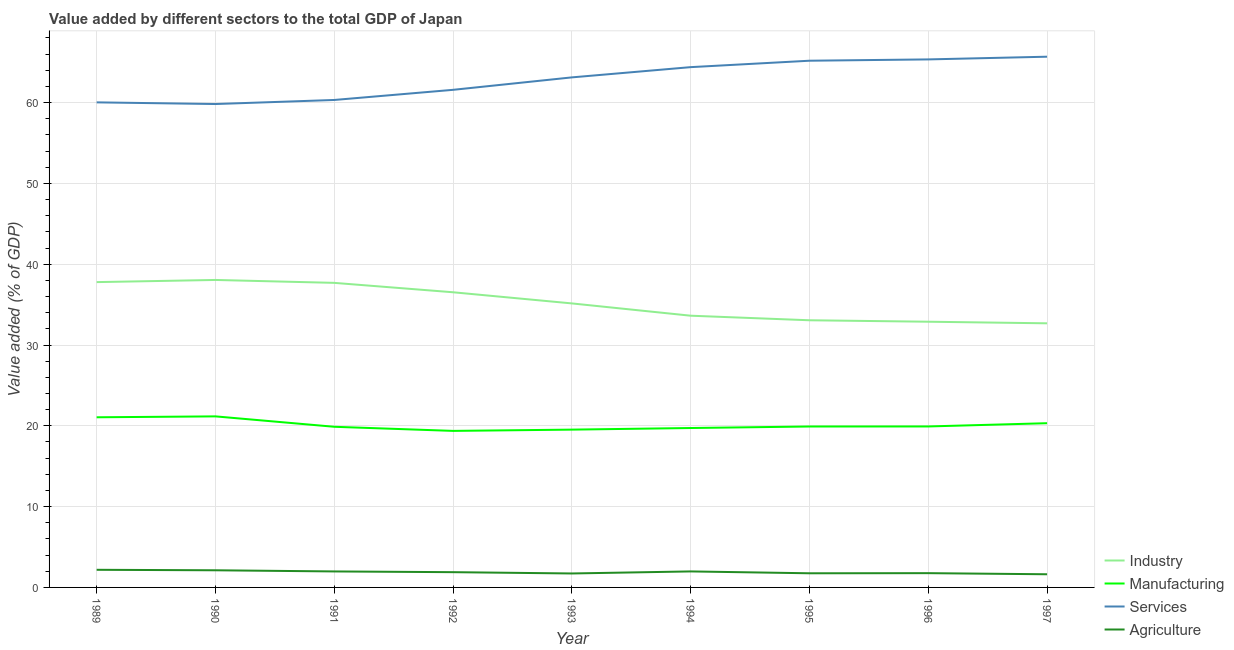How many different coloured lines are there?
Your answer should be compact. 4. Does the line corresponding to value added by manufacturing sector intersect with the line corresponding to value added by agricultural sector?
Offer a terse response. No. Is the number of lines equal to the number of legend labels?
Your response must be concise. Yes. What is the value added by agricultural sector in 1992?
Your response must be concise. 1.89. Across all years, what is the maximum value added by manufacturing sector?
Offer a terse response. 21.17. Across all years, what is the minimum value added by services sector?
Your response must be concise. 59.82. In which year was the value added by industrial sector maximum?
Your response must be concise. 1990. What is the total value added by manufacturing sector in the graph?
Make the answer very short. 180.9. What is the difference between the value added by agricultural sector in 1992 and that in 1997?
Your answer should be very brief. 0.26. What is the difference between the value added by services sector in 1997 and the value added by industrial sector in 1994?
Provide a succinct answer. 32.05. What is the average value added by services sector per year?
Make the answer very short. 62.83. In the year 1996, what is the difference between the value added by agricultural sector and value added by services sector?
Your answer should be compact. -63.58. In how many years, is the value added by manufacturing sector greater than 2 %?
Offer a terse response. 9. What is the ratio of the value added by industrial sector in 1993 to that in 1997?
Offer a very short reply. 1.08. What is the difference between the highest and the second highest value added by agricultural sector?
Offer a very short reply. 0.06. What is the difference between the highest and the lowest value added by agricultural sector?
Offer a terse response. 0.55. In how many years, is the value added by manufacturing sector greater than the average value added by manufacturing sector taken over all years?
Your answer should be very brief. 3. Is it the case that in every year, the sum of the value added by industrial sector and value added by manufacturing sector is greater than the value added by services sector?
Offer a terse response. No. Is the value added by industrial sector strictly greater than the value added by manufacturing sector over the years?
Ensure brevity in your answer.  Yes. Is the value added by industrial sector strictly less than the value added by services sector over the years?
Your response must be concise. Yes. How many lines are there?
Keep it short and to the point. 4. What is the difference between two consecutive major ticks on the Y-axis?
Make the answer very short. 10. What is the title of the graph?
Provide a succinct answer. Value added by different sectors to the total GDP of Japan. Does "HFC gas" appear as one of the legend labels in the graph?
Ensure brevity in your answer.  No. What is the label or title of the X-axis?
Make the answer very short. Year. What is the label or title of the Y-axis?
Ensure brevity in your answer.  Value added (% of GDP). What is the Value added (% of GDP) of Industry in 1989?
Keep it short and to the point. 37.79. What is the Value added (% of GDP) in Manufacturing in 1989?
Your answer should be very brief. 21.06. What is the Value added (% of GDP) of Services in 1989?
Your answer should be very brief. 60.03. What is the Value added (% of GDP) of Agriculture in 1989?
Give a very brief answer. 2.18. What is the Value added (% of GDP) in Industry in 1990?
Give a very brief answer. 38.05. What is the Value added (% of GDP) of Manufacturing in 1990?
Keep it short and to the point. 21.17. What is the Value added (% of GDP) in Services in 1990?
Offer a terse response. 59.82. What is the Value added (% of GDP) in Agriculture in 1990?
Your response must be concise. 2.12. What is the Value added (% of GDP) in Industry in 1991?
Your answer should be compact. 37.69. What is the Value added (% of GDP) in Manufacturing in 1991?
Provide a succinct answer. 19.88. What is the Value added (% of GDP) in Services in 1991?
Your response must be concise. 60.33. What is the Value added (% of GDP) of Agriculture in 1991?
Make the answer very short. 1.98. What is the Value added (% of GDP) of Industry in 1992?
Provide a short and direct response. 36.53. What is the Value added (% of GDP) in Manufacturing in 1992?
Keep it short and to the point. 19.37. What is the Value added (% of GDP) of Services in 1992?
Provide a succinct answer. 61.58. What is the Value added (% of GDP) in Agriculture in 1992?
Provide a succinct answer. 1.89. What is the Value added (% of GDP) of Industry in 1993?
Provide a short and direct response. 35.15. What is the Value added (% of GDP) in Manufacturing in 1993?
Offer a very short reply. 19.53. What is the Value added (% of GDP) in Services in 1993?
Ensure brevity in your answer.  63.12. What is the Value added (% of GDP) of Agriculture in 1993?
Your answer should be very brief. 1.73. What is the Value added (% of GDP) of Industry in 1994?
Offer a very short reply. 33.63. What is the Value added (% of GDP) in Manufacturing in 1994?
Keep it short and to the point. 19.73. What is the Value added (% of GDP) of Services in 1994?
Your answer should be compact. 64.39. What is the Value added (% of GDP) of Agriculture in 1994?
Your answer should be very brief. 1.98. What is the Value added (% of GDP) in Industry in 1995?
Your answer should be very brief. 33.06. What is the Value added (% of GDP) of Manufacturing in 1995?
Provide a succinct answer. 19.92. What is the Value added (% of GDP) in Services in 1995?
Keep it short and to the point. 65.19. What is the Value added (% of GDP) in Agriculture in 1995?
Provide a short and direct response. 1.75. What is the Value added (% of GDP) in Industry in 1996?
Keep it short and to the point. 32.88. What is the Value added (% of GDP) of Manufacturing in 1996?
Offer a very short reply. 19.92. What is the Value added (% of GDP) of Services in 1996?
Offer a very short reply. 65.35. What is the Value added (% of GDP) in Agriculture in 1996?
Your answer should be compact. 1.77. What is the Value added (% of GDP) of Industry in 1997?
Provide a short and direct response. 32.69. What is the Value added (% of GDP) in Manufacturing in 1997?
Your response must be concise. 20.32. What is the Value added (% of GDP) of Services in 1997?
Your response must be concise. 65.68. What is the Value added (% of GDP) of Agriculture in 1997?
Your answer should be compact. 1.63. Across all years, what is the maximum Value added (% of GDP) in Industry?
Provide a succinct answer. 38.05. Across all years, what is the maximum Value added (% of GDP) in Manufacturing?
Ensure brevity in your answer.  21.17. Across all years, what is the maximum Value added (% of GDP) of Services?
Provide a succinct answer. 65.68. Across all years, what is the maximum Value added (% of GDP) in Agriculture?
Ensure brevity in your answer.  2.18. Across all years, what is the minimum Value added (% of GDP) in Industry?
Keep it short and to the point. 32.69. Across all years, what is the minimum Value added (% of GDP) of Manufacturing?
Your answer should be compact. 19.37. Across all years, what is the minimum Value added (% of GDP) of Services?
Keep it short and to the point. 59.82. Across all years, what is the minimum Value added (% of GDP) of Agriculture?
Ensure brevity in your answer.  1.63. What is the total Value added (% of GDP) in Industry in the graph?
Keep it short and to the point. 317.48. What is the total Value added (% of GDP) of Manufacturing in the graph?
Ensure brevity in your answer.  180.9. What is the total Value added (% of GDP) of Services in the graph?
Offer a terse response. 565.5. What is the total Value added (% of GDP) of Agriculture in the graph?
Your answer should be compact. 17.02. What is the difference between the Value added (% of GDP) in Industry in 1989 and that in 1990?
Keep it short and to the point. -0.27. What is the difference between the Value added (% of GDP) of Manufacturing in 1989 and that in 1990?
Your response must be concise. -0.11. What is the difference between the Value added (% of GDP) in Services in 1989 and that in 1990?
Keep it short and to the point. 0.21. What is the difference between the Value added (% of GDP) in Agriculture in 1989 and that in 1990?
Your response must be concise. 0.06. What is the difference between the Value added (% of GDP) in Industry in 1989 and that in 1991?
Your answer should be very brief. 0.09. What is the difference between the Value added (% of GDP) in Manufacturing in 1989 and that in 1991?
Your answer should be compact. 1.17. What is the difference between the Value added (% of GDP) of Services in 1989 and that in 1991?
Provide a succinct answer. -0.3. What is the difference between the Value added (% of GDP) in Agriculture in 1989 and that in 1991?
Your answer should be compact. 0.2. What is the difference between the Value added (% of GDP) of Industry in 1989 and that in 1992?
Provide a succinct answer. 1.26. What is the difference between the Value added (% of GDP) of Manufacturing in 1989 and that in 1992?
Make the answer very short. 1.68. What is the difference between the Value added (% of GDP) in Services in 1989 and that in 1992?
Give a very brief answer. -1.55. What is the difference between the Value added (% of GDP) of Agriculture in 1989 and that in 1992?
Give a very brief answer. 0.3. What is the difference between the Value added (% of GDP) of Industry in 1989 and that in 1993?
Provide a succinct answer. 2.64. What is the difference between the Value added (% of GDP) of Manufacturing in 1989 and that in 1993?
Offer a very short reply. 1.53. What is the difference between the Value added (% of GDP) of Services in 1989 and that in 1993?
Provide a short and direct response. -3.09. What is the difference between the Value added (% of GDP) in Agriculture in 1989 and that in 1993?
Ensure brevity in your answer.  0.45. What is the difference between the Value added (% of GDP) in Industry in 1989 and that in 1994?
Your response must be concise. 4.16. What is the difference between the Value added (% of GDP) in Manufacturing in 1989 and that in 1994?
Offer a very short reply. 1.33. What is the difference between the Value added (% of GDP) in Services in 1989 and that in 1994?
Keep it short and to the point. -4.36. What is the difference between the Value added (% of GDP) in Agriculture in 1989 and that in 1994?
Make the answer very short. 0.2. What is the difference between the Value added (% of GDP) of Industry in 1989 and that in 1995?
Give a very brief answer. 4.72. What is the difference between the Value added (% of GDP) in Manufacturing in 1989 and that in 1995?
Offer a very short reply. 1.14. What is the difference between the Value added (% of GDP) of Services in 1989 and that in 1995?
Your answer should be very brief. -5.15. What is the difference between the Value added (% of GDP) of Agriculture in 1989 and that in 1995?
Offer a terse response. 0.43. What is the difference between the Value added (% of GDP) in Industry in 1989 and that in 1996?
Ensure brevity in your answer.  4.9. What is the difference between the Value added (% of GDP) in Manufacturing in 1989 and that in 1996?
Offer a terse response. 1.13. What is the difference between the Value added (% of GDP) of Services in 1989 and that in 1996?
Your response must be concise. -5.32. What is the difference between the Value added (% of GDP) in Agriculture in 1989 and that in 1996?
Your answer should be compact. 0.42. What is the difference between the Value added (% of GDP) in Industry in 1989 and that in 1997?
Provide a succinct answer. 5.1. What is the difference between the Value added (% of GDP) of Manufacturing in 1989 and that in 1997?
Keep it short and to the point. 0.73. What is the difference between the Value added (% of GDP) in Services in 1989 and that in 1997?
Your response must be concise. -5.65. What is the difference between the Value added (% of GDP) in Agriculture in 1989 and that in 1997?
Ensure brevity in your answer.  0.55. What is the difference between the Value added (% of GDP) in Industry in 1990 and that in 1991?
Make the answer very short. 0.36. What is the difference between the Value added (% of GDP) in Manufacturing in 1990 and that in 1991?
Your response must be concise. 1.29. What is the difference between the Value added (% of GDP) in Services in 1990 and that in 1991?
Your answer should be very brief. -0.5. What is the difference between the Value added (% of GDP) in Agriculture in 1990 and that in 1991?
Your response must be concise. 0.14. What is the difference between the Value added (% of GDP) in Industry in 1990 and that in 1992?
Provide a succinct answer. 1.52. What is the difference between the Value added (% of GDP) of Manufacturing in 1990 and that in 1992?
Provide a short and direct response. 1.8. What is the difference between the Value added (% of GDP) in Services in 1990 and that in 1992?
Your response must be concise. -1.76. What is the difference between the Value added (% of GDP) of Agriculture in 1990 and that in 1992?
Keep it short and to the point. 0.23. What is the difference between the Value added (% of GDP) in Industry in 1990 and that in 1993?
Offer a terse response. 2.9. What is the difference between the Value added (% of GDP) in Manufacturing in 1990 and that in 1993?
Make the answer very short. 1.64. What is the difference between the Value added (% of GDP) of Services in 1990 and that in 1993?
Your answer should be compact. -3.3. What is the difference between the Value added (% of GDP) of Agriculture in 1990 and that in 1993?
Ensure brevity in your answer.  0.39. What is the difference between the Value added (% of GDP) of Industry in 1990 and that in 1994?
Your answer should be very brief. 4.42. What is the difference between the Value added (% of GDP) of Manufacturing in 1990 and that in 1994?
Provide a short and direct response. 1.44. What is the difference between the Value added (% of GDP) of Services in 1990 and that in 1994?
Make the answer very short. -4.57. What is the difference between the Value added (% of GDP) in Agriculture in 1990 and that in 1994?
Give a very brief answer. 0.14. What is the difference between the Value added (% of GDP) in Industry in 1990 and that in 1995?
Your response must be concise. 4.99. What is the difference between the Value added (% of GDP) of Manufacturing in 1990 and that in 1995?
Provide a succinct answer. 1.25. What is the difference between the Value added (% of GDP) of Services in 1990 and that in 1995?
Provide a short and direct response. -5.36. What is the difference between the Value added (% of GDP) of Agriculture in 1990 and that in 1995?
Make the answer very short. 0.37. What is the difference between the Value added (% of GDP) in Industry in 1990 and that in 1996?
Offer a very short reply. 5.17. What is the difference between the Value added (% of GDP) of Manufacturing in 1990 and that in 1996?
Give a very brief answer. 1.25. What is the difference between the Value added (% of GDP) in Services in 1990 and that in 1996?
Ensure brevity in your answer.  -5.52. What is the difference between the Value added (% of GDP) of Agriculture in 1990 and that in 1996?
Your response must be concise. 0.35. What is the difference between the Value added (% of GDP) in Industry in 1990 and that in 1997?
Offer a terse response. 5.37. What is the difference between the Value added (% of GDP) of Manufacturing in 1990 and that in 1997?
Offer a terse response. 0.84. What is the difference between the Value added (% of GDP) of Services in 1990 and that in 1997?
Your answer should be very brief. -5.86. What is the difference between the Value added (% of GDP) of Agriculture in 1990 and that in 1997?
Give a very brief answer. 0.49. What is the difference between the Value added (% of GDP) of Industry in 1991 and that in 1992?
Give a very brief answer. 1.16. What is the difference between the Value added (% of GDP) in Manufacturing in 1991 and that in 1992?
Provide a succinct answer. 0.51. What is the difference between the Value added (% of GDP) of Services in 1991 and that in 1992?
Your answer should be compact. -1.25. What is the difference between the Value added (% of GDP) in Agriculture in 1991 and that in 1992?
Make the answer very short. 0.09. What is the difference between the Value added (% of GDP) of Industry in 1991 and that in 1993?
Ensure brevity in your answer.  2.54. What is the difference between the Value added (% of GDP) of Manufacturing in 1991 and that in 1993?
Provide a short and direct response. 0.35. What is the difference between the Value added (% of GDP) in Services in 1991 and that in 1993?
Your answer should be compact. -2.79. What is the difference between the Value added (% of GDP) in Agriculture in 1991 and that in 1993?
Ensure brevity in your answer.  0.25. What is the difference between the Value added (% of GDP) of Industry in 1991 and that in 1994?
Make the answer very short. 4.06. What is the difference between the Value added (% of GDP) of Manufacturing in 1991 and that in 1994?
Give a very brief answer. 0.15. What is the difference between the Value added (% of GDP) of Services in 1991 and that in 1994?
Make the answer very short. -4.06. What is the difference between the Value added (% of GDP) in Agriculture in 1991 and that in 1994?
Your answer should be very brief. -0. What is the difference between the Value added (% of GDP) of Industry in 1991 and that in 1995?
Ensure brevity in your answer.  4.63. What is the difference between the Value added (% of GDP) in Manufacturing in 1991 and that in 1995?
Make the answer very short. -0.03. What is the difference between the Value added (% of GDP) in Services in 1991 and that in 1995?
Give a very brief answer. -4.86. What is the difference between the Value added (% of GDP) in Agriculture in 1991 and that in 1995?
Keep it short and to the point. 0.23. What is the difference between the Value added (% of GDP) in Industry in 1991 and that in 1996?
Your answer should be compact. 4.81. What is the difference between the Value added (% of GDP) of Manufacturing in 1991 and that in 1996?
Your answer should be very brief. -0.04. What is the difference between the Value added (% of GDP) in Services in 1991 and that in 1996?
Your answer should be compact. -5.02. What is the difference between the Value added (% of GDP) of Agriculture in 1991 and that in 1996?
Provide a succinct answer. 0.21. What is the difference between the Value added (% of GDP) in Industry in 1991 and that in 1997?
Your answer should be compact. 5. What is the difference between the Value added (% of GDP) of Manufacturing in 1991 and that in 1997?
Provide a succinct answer. -0.44. What is the difference between the Value added (% of GDP) of Services in 1991 and that in 1997?
Your response must be concise. -5.35. What is the difference between the Value added (% of GDP) of Agriculture in 1991 and that in 1997?
Your answer should be very brief. 0.35. What is the difference between the Value added (% of GDP) of Industry in 1992 and that in 1993?
Ensure brevity in your answer.  1.38. What is the difference between the Value added (% of GDP) of Manufacturing in 1992 and that in 1993?
Provide a succinct answer. -0.16. What is the difference between the Value added (% of GDP) in Services in 1992 and that in 1993?
Offer a very short reply. -1.54. What is the difference between the Value added (% of GDP) of Agriculture in 1992 and that in 1993?
Your response must be concise. 0.16. What is the difference between the Value added (% of GDP) of Industry in 1992 and that in 1994?
Provide a succinct answer. 2.9. What is the difference between the Value added (% of GDP) in Manufacturing in 1992 and that in 1994?
Offer a very short reply. -0.36. What is the difference between the Value added (% of GDP) in Services in 1992 and that in 1994?
Your response must be concise. -2.81. What is the difference between the Value added (% of GDP) in Agriculture in 1992 and that in 1994?
Make the answer very short. -0.09. What is the difference between the Value added (% of GDP) in Industry in 1992 and that in 1995?
Give a very brief answer. 3.47. What is the difference between the Value added (% of GDP) of Manufacturing in 1992 and that in 1995?
Your answer should be compact. -0.54. What is the difference between the Value added (% of GDP) of Services in 1992 and that in 1995?
Offer a terse response. -3.6. What is the difference between the Value added (% of GDP) in Agriculture in 1992 and that in 1995?
Offer a terse response. 0.14. What is the difference between the Value added (% of GDP) in Industry in 1992 and that in 1996?
Provide a succinct answer. 3.64. What is the difference between the Value added (% of GDP) of Manufacturing in 1992 and that in 1996?
Your response must be concise. -0.55. What is the difference between the Value added (% of GDP) in Services in 1992 and that in 1996?
Your answer should be very brief. -3.76. What is the difference between the Value added (% of GDP) in Agriculture in 1992 and that in 1996?
Your answer should be compact. 0.12. What is the difference between the Value added (% of GDP) of Industry in 1992 and that in 1997?
Your answer should be very brief. 3.84. What is the difference between the Value added (% of GDP) in Manufacturing in 1992 and that in 1997?
Ensure brevity in your answer.  -0.95. What is the difference between the Value added (% of GDP) in Services in 1992 and that in 1997?
Offer a very short reply. -4.1. What is the difference between the Value added (% of GDP) in Agriculture in 1992 and that in 1997?
Your answer should be compact. 0.26. What is the difference between the Value added (% of GDP) of Industry in 1993 and that in 1994?
Your answer should be compact. 1.52. What is the difference between the Value added (% of GDP) of Manufacturing in 1993 and that in 1994?
Make the answer very short. -0.2. What is the difference between the Value added (% of GDP) of Services in 1993 and that in 1994?
Ensure brevity in your answer.  -1.27. What is the difference between the Value added (% of GDP) in Agriculture in 1993 and that in 1994?
Offer a terse response. -0.25. What is the difference between the Value added (% of GDP) in Industry in 1993 and that in 1995?
Offer a very short reply. 2.09. What is the difference between the Value added (% of GDP) in Manufacturing in 1993 and that in 1995?
Your response must be concise. -0.38. What is the difference between the Value added (% of GDP) of Services in 1993 and that in 1995?
Keep it short and to the point. -2.06. What is the difference between the Value added (% of GDP) in Agriculture in 1993 and that in 1995?
Provide a short and direct response. -0.02. What is the difference between the Value added (% of GDP) of Industry in 1993 and that in 1996?
Keep it short and to the point. 2.26. What is the difference between the Value added (% of GDP) in Manufacturing in 1993 and that in 1996?
Provide a short and direct response. -0.39. What is the difference between the Value added (% of GDP) of Services in 1993 and that in 1996?
Ensure brevity in your answer.  -2.23. What is the difference between the Value added (% of GDP) of Agriculture in 1993 and that in 1996?
Keep it short and to the point. -0.04. What is the difference between the Value added (% of GDP) in Industry in 1993 and that in 1997?
Provide a short and direct response. 2.46. What is the difference between the Value added (% of GDP) in Manufacturing in 1993 and that in 1997?
Offer a terse response. -0.79. What is the difference between the Value added (% of GDP) in Services in 1993 and that in 1997?
Make the answer very short. -2.56. What is the difference between the Value added (% of GDP) in Agriculture in 1993 and that in 1997?
Give a very brief answer. 0.1. What is the difference between the Value added (% of GDP) in Industry in 1994 and that in 1995?
Offer a very short reply. 0.57. What is the difference between the Value added (% of GDP) in Manufacturing in 1994 and that in 1995?
Give a very brief answer. -0.19. What is the difference between the Value added (% of GDP) in Services in 1994 and that in 1995?
Your answer should be very brief. -0.8. What is the difference between the Value added (% of GDP) in Agriculture in 1994 and that in 1995?
Your answer should be very brief. 0.23. What is the difference between the Value added (% of GDP) of Industry in 1994 and that in 1996?
Offer a terse response. 0.74. What is the difference between the Value added (% of GDP) of Manufacturing in 1994 and that in 1996?
Offer a very short reply. -0.19. What is the difference between the Value added (% of GDP) in Services in 1994 and that in 1996?
Your answer should be compact. -0.96. What is the difference between the Value added (% of GDP) in Agriculture in 1994 and that in 1996?
Your answer should be compact. 0.21. What is the difference between the Value added (% of GDP) of Industry in 1994 and that in 1997?
Provide a short and direct response. 0.94. What is the difference between the Value added (% of GDP) of Manufacturing in 1994 and that in 1997?
Keep it short and to the point. -0.59. What is the difference between the Value added (% of GDP) in Services in 1994 and that in 1997?
Offer a terse response. -1.29. What is the difference between the Value added (% of GDP) in Agriculture in 1994 and that in 1997?
Ensure brevity in your answer.  0.35. What is the difference between the Value added (% of GDP) in Industry in 1995 and that in 1996?
Offer a very short reply. 0.18. What is the difference between the Value added (% of GDP) in Manufacturing in 1995 and that in 1996?
Offer a terse response. -0.01. What is the difference between the Value added (% of GDP) in Services in 1995 and that in 1996?
Give a very brief answer. -0.16. What is the difference between the Value added (% of GDP) of Agriculture in 1995 and that in 1996?
Keep it short and to the point. -0.02. What is the difference between the Value added (% of GDP) of Industry in 1995 and that in 1997?
Make the answer very short. 0.38. What is the difference between the Value added (% of GDP) of Manufacturing in 1995 and that in 1997?
Offer a terse response. -0.41. What is the difference between the Value added (% of GDP) of Services in 1995 and that in 1997?
Provide a succinct answer. -0.5. What is the difference between the Value added (% of GDP) in Agriculture in 1995 and that in 1997?
Make the answer very short. 0.12. What is the difference between the Value added (% of GDP) of Industry in 1996 and that in 1997?
Offer a terse response. 0.2. What is the difference between the Value added (% of GDP) of Manufacturing in 1996 and that in 1997?
Your answer should be compact. -0.4. What is the difference between the Value added (% of GDP) in Services in 1996 and that in 1997?
Provide a succinct answer. -0.33. What is the difference between the Value added (% of GDP) of Agriculture in 1996 and that in 1997?
Ensure brevity in your answer.  0.14. What is the difference between the Value added (% of GDP) of Industry in 1989 and the Value added (% of GDP) of Manufacturing in 1990?
Your answer should be very brief. 16.62. What is the difference between the Value added (% of GDP) of Industry in 1989 and the Value added (% of GDP) of Services in 1990?
Provide a succinct answer. -22.04. What is the difference between the Value added (% of GDP) in Industry in 1989 and the Value added (% of GDP) in Agriculture in 1990?
Your answer should be very brief. 35.66. What is the difference between the Value added (% of GDP) of Manufacturing in 1989 and the Value added (% of GDP) of Services in 1990?
Your response must be concise. -38.77. What is the difference between the Value added (% of GDP) in Manufacturing in 1989 and the Value added (% of GDP) in Agriculture in 1990?
Your response must be concise. 18.94. What is the difference between the Value added (% of GDP) in Services in 1989 and the Value added (% of GDP) in Agriculture in 1990?
Make the answer very short. 57.91. What is the difference between the Value added (% of GDP) in Industry in 1989 and the Value added (% of GDP) in Manufacturing in 1991?
Your response must be concise. 17.9. What is the difference between the Value added (% of GDP) in Industry in 1989 and the Value added (% of GDP) in Services in 1991?
Offer a very short reply. -22.54. What is the difference between the Value added (% of GDP) in Industry in 1989 and the Value added (% of GDP) in Agriculture in 1991?
Provide a short and direct response. 35.81. What is the difference between the Value added (% of GDP) of Manufacturing in 1989 and the Value added (% of GDP) of Services in 1991?
Keep it short and to the point. -39.27. What is the difference between the Value added (% of GDP) in Manufacturing in 1989 and the Value added (% of GDP) in Agriculture in 1991?
Offer a terse response. 19.08. What is the difference between the Value added (% of GDP) in Services in 1989 and the Value added (% of GDP) in Agriculture in 1991?
Provide a short and direct response. 58.05. What is the difference between the Value added (% of GDP) of Industry in 1989 and the Value added (% of GDP) of Manufacturing in 1992?
Your response must be concise. 18.41. What is the difference between the Value added (% of GDP) of Industry in 1989 and the Value added (% of GDP) of Services in 1992?
Give a very brief answer. -23.8. What is the difference between the Value added (% of GDP) in Industry in 1989 and the Value added (% of GDP) in Agriculture in 1992?
Ensure brevity in your answer.  35.9. What is the difference between the Value added (% of GDP) of Manufacturing in 1989 and the Value added (% of GDP) of Services in 1992?
Offer a very short reply. -40.53. What is the difference between the Value added (% of GDP) in Manufacturing in 1989 and the Value added (% of GDP) in Agriculture in 1992?
Provide a short and direct response. 19.17. What is the difference between the Value added (% of GDP) in Services in 1989 and the Value added (% of GDP) in Agriculture in 1992?
Ensure brevity in your answer.  58.14. What is the difference between the Value added (% of GDP) of Industry in 1989 and the Value added (% of GDP) of Manufacturing in 1993?
Offer a very short reply. 18.26. What is the difference between the Value added (% of GDP) of Industry in 1989 and the Value added (% of GDP) of Services in 1993?
Provide a short and direct response. -25.34. What is the difference between the Value added (% of GDP) of Industry in 1989 and the Value added (% of GDP) of Agriculture in 1993?
Provide a succinct answer. 36.06. What is the difference between the Value added (% of GDP) of Manufacturing in 1989 and the Value added (% of GDP) of Services in 1993?
Keep it short and to the point. -42.07. What is the difference between the Value added (% of GDP) of Manufacturing in 1989 and the Value added (% of GDP) of Agriculture in 1993?
Offer a very short reply. 19.33. What is the difference between the Value added (% of GDP) in Services in 1989 and the Value added (% of GDP) in Agriculture in 1993?
Give a very brief answer. 58.3. What is the difference between the Value added (% of GDP) of Industry in 1989 and the Value added (% of GDP) of Manufacturing in 1994?
Offer a very short reply. 18.06. What is the difference between the Value added (% of GDP) of Industry in 1989 and the Value added (% of GDP) of Services in 1994?
Your answer should be compact. -26.61. What is the difference between the Value added (% of GDP) of Industry in 1989 and the Value added (% of GDP) of Agriculture in 1994?
Your answer should be compact. 35.81. What is the difference between the Value added (% of GDP) in Manufacturing in 1989 and the Value added (% of GDP) in Services in 1994?
Keep it short and to the point. -43.33. What is the difference between the Value added (% of GDP) of Manufacturing in 1989 and the Value added (% of GDP) of Agriculture in 1994?
Give a very brief answer. 19.08. What is the difference between the Value added (% of GDP) of Services in 1989 and the Value added (% of GDP) of Agriculture in 1994?
Keep it short and to the point. 58.05. What is the difference between the Value added (% of GDP) in Industry in 1989 and the Value added (% of GDP) in Manufacturing in 1995?
Your response must be concise. 17.87. What is the difference between the Value added (% of GDP) in Industry in 1989 and the Value added (% of GDP) in Services in 1995?
Your response must be concise. -27.4. What is the difference between the Value added (% of GDP) of Industry in 1989 and the Value added (% of GDP) of Agriculture in 1995?
Your answer should be compact. 36.04. What is the difference between the Value added (% of GDP) of Manufacturing in 1989 and the Value added (% of GDP) of Services in 1995?
Your answer should be compact. -44.13. What is the difference between the Value added (% of GDP) of Manufacturing in 1989 and the Value added (% of GDP) of Agriculture in 1995?
Your response must be concise. 19.31. What is the difference between the Value added (% of GDP) of Services in 1989 and the Value added (% of GDP) of Agriculture in 1995?
Ensure brevity in your answer.  58.28. What is the difference between the Value added (% of GDP) of Industry in 1989 and the Value added (% of GDP) of Manufacturing in 1996?
Provide a succinct answer. 17.86. What is the difference between the Value added (% of GDP) of Industry in 1989 and the Value added (% of GDP) of Services in 1996?
Keep it short and to the point. -27.56. What is the difference between the Value added (% of GDP) in Industry in 1989 and the Value added (% of GDP) in Agriculture in 1996?
Ensure brevity in your answer.  36.02. What is the difference between the Value added (% of GDP) of Manufacturing in 1989 and the Value added (% of GDP) of Services in 1996?
Your response must be concise. -44.29. What is the difference between the Value added (% of GDP) of Manufacturing in 1989 and the Value added (% of GDP) of Agriculture in 1996?
Keep it short and to the point. 19.29. What is the difference between the Value added (% of GDP) in Services in 1989 and the Value added (% of GDP) in Agriculture in 1996?
Provide a short and direct response. 58.27. What is the difference between the Value added (% of GDP) in Industry in 1989 and the Value added (% of GDP) in Manufacturing in 1997?
Ensure brevity in your answer.  17.46. What is the difference between the Value added (% of GDP) of Industry in 1989 and the Value added (% of GDP) of Services in 1997?
Make the answer very short. -27.9. What is the difference between the Value added (% of GDP) in Industry in 1989 and the Value added (% of GDP) in Agriculture in 1997?
Your answer should be very brief. 36.16. What is the difference between the Value added (% of GDP) of Manufacturing in 1989 and the Value added (% of GDP) of Services in 1997?
Offer a very short reply. -44.63. What is the difference between the Value added (% of GDP) in Manufacturing in 1989 and the Value added (% of GDP) in Agriculture in 1997?
Ensure brevity in your answer.  19.43. What is the difference between the Value added (% of GDP) in Services in 1989 and the Value added (% of GDP) in Agriculture in 1997?
Ensure brevity in your answer.  58.4. What is the difference between the Value added (% of GDP) in Industry in 1990 and the Value added (% of GDP) in Manufacturing in 1991?
Offer a very short reply. 18.17. What is the difference between the Value added (% of GDP) in Industry in 1990 and the Value added (% of GDP) in Services in 1991?
Give a very brief answer. -22.27. What is the difference between the Value added (% of GDP) of Industry in 1990 and the Value added (% of GDP) of Agriculture in 1991?
Make the answer very short. 36.08. What is the difference between the Value added (% of GDP) of Manufacturing in 1990 and the Value added (% of GDP) of Services in 1991?
Ensure brevity in your answer.  -39.16. What is the difference between the Value added (% of GDP) of Manufacturing in 1990 and the Value added (% of GDP) of Agriculture in 1991?
Your answer should be compact. 19.19. What is the difference between the Value added (% of GDP) of Services in 1990 and the Value added (% of GDP) of Agriculture in 1991?
Give a very brief answer. 57.85. What is the difference between the Value added (% of GDP) in Industry in 1990 and the Value added (% of GDP) in Manufacturing in 1992?
Your response must be concise. 18.68. What is the difference between the Value added (% of GDP) of Industry in 1990 and the Value added (% of GDP) of Services in 1992?
Make the answer very short. -23.53. What is the difference between the Value added (% of GDP) in Industry in 1990 and the Value added (% of GDP) in Agriculture in 1992?
Keep it short and to the point. 36.17. What is the difference between the Value added (% of GDP) in Manufacturing in 1990 and the Value added (% of GDP) in Services in 1992?
Your answer should be compact. -40.41. What is the difference between the Value added (% of GDP) of Manufacturing in 1990 and the Value added (% of GDP) of Agriculture in 1992?
Offer a terse response. 19.28. What is the difference between the Value added (% of GDP) in Services in 1990 and the Value added (% of GDP) in Agriculture in 1992?
Offer a very short reply. 57.94. What is the difference between the Value added (% of GDP) in Industry in 1990 and the Value added (% of GDP) in Manufacturing in 1993?
Ensure brevity in your answer.  18.52. What is the difference between the Value added (% of GDP) of Industry in 1990 and the Value added (% of GDP) of Services in 1993?
Keep it short and to the point. -25.07. What is the difference between the Value added (% of GDP) of Industry in 1990 and the Value added (% of GDP) of Agriculture in 1993?
Offer a terse response. 36.33. What is the difference between the Value added (% of GDP) of Manufacturing in 1990 and the Value added (% of GDP) of Services in 1993?
Your answer should be very brief. -41.95. What is the difference between the Value added (% of GDP) of Manufacturing in 1990 and the Value added (% of GDP) of Agriculture in 1993?
Give a very brief answer. 19.44. What is the difference between the Value added (% of GDP) of Services in 1990 and the Value added (% of GDP) of Agriculture in 1993?
Your answer should be very brief. 58.1. What is the difference between the Value added (% of GDP) in Industry in 1990 and the Value added (% of GDP) in Manufacturing in 1994?
Offer a terse response. 18.32. What is the difference between the Value added (% of GDP) in Industry in 1990 and the Value added (% of GDP) in Services in 1994?
Offer a terse response. -26.34. What is the difference between the Value added (% of GDP) of Industry in 1990 and the Value added (% of GDP) of Agriculture in 1994?
Give a very brief answer. 36.07. What is the difference between the Value added (% of GDP) of Manufacturing in 1990 and the Value added (% of GDP) of Services in 1994?
Provide a succinct answer. -43.22. What is the difference between the Value added (% of GDP) in Manufacturing in 1990 and the Value added (% of GDP) in Agriculture in 1994?
Offer a terse response. 19.19. What is the difference between the Value added (% of GDP) of Services in 1990 and the Value added (% of GDP) of Agriculture in 1994?
Your answer should be very brief. 57.84. What is the difference between the Value added (% of GDP) in Industry in 1990 and the Value added (% of GDP) in Manufacturing in 1995?
Provide a short and direct response. 18.14. What is the difference between the Value added (% of GDP) in Industry in 1990 and the Value added (% of GDP) in Services in 1995?
Your response must be concise. -27.13. What is the difference between the Value added (% of GDP) of Industry in 1990 and the Value added (% of GDP) of Agriculture in 1995?
Keep it short and to the point. 36.3. What is the difference between the Value added (% of GDP) in Manufacturing in 1990 and the Value added (% of GDP) in Services in 1995?
Give a very brief answer. -44.02. What is the difference between the Value added (% of GDP) in Manufacturing in 1990 and the Value added (% of GDP) in Agriculture in 1995?
Provide a succinct answer. 19.42. What is the difference between the Value added (% of GDP) of Services in 1990 and the Value added (% of GDP) of Agriculture in 1995?
Give a very brief answer. 58.07. What is the difference between the Value added (% of GDP) in Industry in 1990 and the Value added (% of GDP) in Manufacturing in 1996?
Give a very brief answer. 18.13. What is the difference between the Value added (% of GDP) of Industry in 1990 and the Value added (% of GDP) of Services in 1996?
Make the answer very short. -27.29. What is the difference between the Value added (% of GDP) in Industry in 1990 and the Value added (% of GDP) in Agriculture in 1996?
Provide a succinct answer. 36.29. What is the difference between the Value added (% of GDP) in Manufacturing in 1990 and the Value added (% of GDP) in Services in 1996?
Your answer should be compact. -44.18. What is the difference between the Value added (% of GDP) of Manufacturing in 1990 and the Value added (% of GDP) of Agriculture in 1996?
Make the answer very short. 19.4. What is the difference between the Value added (% of GDP) in Services in 1990 and the Value added (% of GDP) in Agriculture in 1996?
Provide a short and direct response. 58.06. What is the difference between the Value added (% of GDP) in Industry in 1990 and the Value added (% of GDP) in Manufacturing in 1997?
Your answer should be very brief. 17.73. What is the difference between the Value added (% of GDP) in Industry in 1990 and the Value added (% of GDP) in Services in 1997?
Keep it short and to the point. -27.63. What is the difference between the Value added (% of GDP) in Industry in 1990 and the Value added (% of GDP) in Agriculture in 1997?
Ensure brevity in your answer.  36.42. What is the difference between the Value added (% of GDP) in Manufacturing in 1990 and the Value added (% of GDP) in Services in 1997?
Your response must be concise. -44.51. What is the difference between the Value added (% of GDP) of Manufacturing in 1990 and the Value added (% of GDP) of Agriculture in 1997?
Offer a terse response. 19.54. What is the difference between the Value added (% of GDP) in Services in 1990 and the Value added (% of GDP) in Agriculture in 1997?
Your response must be concise. 58.2. What is the difference between the Value added (% of GDP) in Industry in 1991 and the Value added (% of GDP) in Manufacturing in 1992?
Your response must be concise. 18.32. What is the difference between the Value added (% of GDP) of Industry in 1991 and the Value added (% of GDP) of Services in 1992?
Your answer should be very brief. -23.89. What is the difference between the Value added (% of GDP) in Industry in 1991 and the Value added (% of GDP) in Agriculture in 1992?
Give a very brief answer. 35.81. What is the difference between the Value added (% of GDP) in Manufacturing in 1991 and the Value added (% of GDP) in Services in 1992?
Offer a very short reply. -41.7. What is the difference between the Value added (% of GDP) of Manufacturing in 1991 and the Value added (% of GDP) of Agriculture in 1992?
Provide a short and direct response. 18. What is the difference between the Value added (% of GDP) in Services in 1991 and the Value added (% of GDP) in Agriculture in 1992?
Ensure brevity in your answer.  58.44. What is the difference between the Value added (% of GDP) of Industry in 1991 and the Value added (% of GDP) of Manufacturing in 1993?
Make the answer very short. 18.16. What is the difference between the Value added (% of GDP) in Industry in 1991 and the Value added (% of GDP) in Services in 1993?
Offer a very short reply. -25.43. What is the difference between the Value added (% of GDP) of Industry in 1991 and the Value added (% of GDP) of Agriculture in 1993?
Provide a succinct answer. 35.97. What is the difference between the Value added (% of GDP) of Manufacturing in 1991 and the Value added (% of GDP) of Services in 1993?
Offer a terse response. -43.24. What is the difference between the Value added (% of GDP) in Manufacturing in 1991 and the Value added (% of GDP) in Agriculture in 1993?
Ensure brevity in your answer.  18.15. What is the difference between the Value added (% of GDP) in Services in 1991 and the Value added (% of GDP) in Agriculture in 1993?
Your answer should be compact. 58.6. What is the difference between the Value added (% of GDP) in Industry in 1991 and the Value added (% of GDP) in Manufacturing in 1994?
Offer a terse response. 17.96. What is the difference between the Value added (% of GDP) of Industry in 1991 and the Value added (% of GDP) of Services in 1994?
Make the answer very short. -26.7. What is the difference between the Value added (% of GDP) in Industry in 1991 and the Value added (% of GDP) in Agriculture in 1994?
Ensure brevity in your answer.  35.71. What is the difference between the Value added (% of GDP) in Manufacturing in 1991 and the Value added (% of GDP) in Services in 1994?
Keep it short and to the point. -44.51. What is the difference between the Value added (% of GDP) of Manufacturing in 1991 and the Value added (% of GDP) of Agriculture in 1994?
Your response must be concise. 17.9. What is the difference between the Value added (% of GDP) in Services in 1991 and the Value added (% of GDP) in Agriculture in 1994?
Provide a short and direct response. 58.35. What is the difference between the Value added (% of GDP) in Industry in 1991 and the Value added (% of GDP) in Manufacturing in 1995?
Provide a succinct answer. 17.78. What is the difference between the Value added (% of GDP) in Industry in 1991 and the Value added (% of GDP) in Services in 1995?
Keep it short and to the point. -27.49. What is the difference between the Value added (% of GDP) of Industry in 1991 and the Value added (% of GDP) of Agriculture in 1995?
Make the answer very short. 35.94. What is the difference between the Value added (% of GDP) in Manufacturing in 1991 and the Value added (% of GDP) in Services in 1995?
Give a very brief answer. -45.3. What is the difference between the Value added (% of GDP) of Manufacturing in 1991 and the Value added (% of GDP) of Agriculture in 1995?
Provide a succinct answer. 18.13. What is the difference between the Value added (% of GDP) of Services in 1991 and the Value added (% of GDP) of Agriculture in 1995?
Your answer should be compact. 58.58. What is the difference between the Value added (% of GDP) in Industry in 1991 and the Value added (% of GDP) in Manufacturing in 1996?
Offer a very short reply. 17.77. What is the difference between the Value added (% of GDP) in Industry in 1991 and the Value added (% of GDP) in Services in 1996?
Your response must be concise. -27.66. What is the difference between the Value added (% of GDP) in Industry in 1991 and the Value added (% of GDP) in Agriculture in 1996?
Make the answer very short. 35.93. What is the difference between the Value added (% of GDP) in Manufacturing in 1991 and the Value added (% of GDP) in Services in 1996?
Your answer should be compact. -45.47. What is the difference between the Value added (% of GDP) of Manufacturing in 1991 and the Value added (% of GDP) of Agriculture in 1996?
Provide a short and direct response. 18.12. What is the difference between the Value added (% of GDP) in Services in 1991 and the Value added (% of GDP) in Agriculture in 1996?
Ensure brevity in your answer.  58.56. What is the difference between the Value added (% of GDP) of Industry in 1991 and the Value added (% of GDP) of Manufacturing in 1997?
Your answer should be compact. 17.37. What is the difference between the Value added (% of GDP) in Industry in 1991 and the Value added (% of GDP) in Services in 1997?
Offer a very short reply. -27.99. What is the difference between the Value added (% of GDP) of Industry in 1991 and the Value added (% of GDP) of Agriculture in 1997?
Your answer should be compact. 36.06. What is the difference between the Value added (% of GDP) in Manufacturing in 1991 and the Value added (% of GDP) in Services in 1997?
Your answer should be compact. -45.8. What is the difference between the Value added (% of GDP) in Manufacturing in 1991 and the Value added (% of GDP) in Agriculture in 1997?
Ensure brevity in your answer.  18.25. What is the difference between the Value added (% of GDP) in Services in 1991 and the Value added (% of GDP) in Agriculture in 1997?
Your answer should be compact. 58.7. What is the difference between the Value added (% of GDP) of Industry in 1992 and the Value added (% of GDP) of Manufacturing in 1993?
Offer a very short reply. 17. What is the difference between the Value added (% of GDP) in Industry in 1992 and the Value added (% of GDP) in Services in 1993?
Provide a succinct answer. -26.59. What is the difference between the Value added (% of GDP) of Industry in 1992 and the Value added (% of GDP) of Agriculture in 1993?
Keep it short and to the point. 34.8. What is the difference between the Value added (% of GDP) of Manufacturing in 1992 and the Value added (% of GDP) of Services in 1993?
Keep it short and to the point. -43.75. What is the difference between the Value added (% of GDP) in Manufacturing in 1992 and the Value added (% of GDP) in Agriculture in 1993?
Provide a succinct answer. 17.65. What is the difference between the Value added (% of GDP) in Services in 1992 and the Value added (% of GDP) in Agriculture in 1993?
Ensure brevity in your answer.  59.86. What is the difference between the Value added (% of GDP) of Industry in 1992 and the Value added (% of GDP) of Manufacturing in 1994?
Ensure brevity in your answer.  16.8. What is the difference between the Value added (% of GDP) of Industry in 1992 and the Value added (% of GDP) of Services in 1994?
Keep it short and to the point. -27.86. What is the difference between the Value added (% of GDP) in Industry in 1992 and the Value added (% of GDP) in Agriculture in 1994?
Ensure brevity in your answer.  34.55. What is the difference between the Value added (% of GDP) in Manufacturing in 1992 and the Value added (% of GDP) in Services in 1994?
Provide a short and direct response. -45.02. What is the difference between the Value added (% of GDP) of Manufacturing in 1992 and the Value added (% of GDP) of Agriculture in 1994?
Provide a short and direct response. 17.39. What is the difference between the Value added (% of GDP) of Services in 1992 and the Value added (% of GDP) of Agriculture in 1994?
Your answer should be compact. 59.6. What is the difference between the Value added (% of GDP) in Industry in 1992 and the Value added (% of GDP) in Manufacturing in 1995?
Ensure brevity in your answer.  16.61. What is the difference between the Value added (% of GDP) in Industry in 1992 and the Value added (% of GDP) in Services in 1995?
Your response must be concise. -28.66. What is the difference between the Value added (% of GDP) in Industry in 1992 and the Value added (% of GDP) in Agriculture in 1995?
Offer a terse response. 34.78. What is the difference between the Value added (% of GDP) of Manufacturing in 1992 and the Value added (% of GDP) of Services in 1995?
Ensure brevity in your answer.  -45.81. What is the difference between the Value added (% of GDP) of Manufacturing in 1992 and the Value added (% of GDP) of Agriculture in 1995?
Ensure brevity in your answer.  17.62. What is the difference between the Value added (% of GDP) of Services in 1992 and the Value added (% of GDP) of Agriculture in 1995?
Make the answer very short. 59.83. What is the difference between the Value added (% of GDP) in Industry in 1992 and the Value added (% of GDP) in Manufacturing in 1996?
Provide a short and direct response. 16.61. What is the difference between the Value added (% of GDP) in Industry in 1992 and the Value added (% of GDP) in Services in 1996?
Your answer should be very brief. -28.82. What is the difference between the Value added (% of GDP) of Industry in 1992 and the Value added (% of GDP) of Agriculture in 1996?
Ensure brevity in your answer.  34.76. What is the difference between the Value added (% of GDP) in Manufacturing in 1992 and the Value added (% of GDP) in Services in 1996?
Offer a terse response. -45.98. What is the difference between the Value added (% of GDP) in Manufacturing in 1992 and the Value added (% of GDP) in Agriculture in 1996?
Your response must be concise. 17.61. What is the difference between the Value added (% of GDP) in Services in 1992 and the Value added (% of GDP) in Agriculture in 1996?
Offer a very short reply. 59.82. What is the difference between the Value added (% of GDP) in Industry in 1992 and the Value added (% of GDP) in Manufacturing in 1997?
Your response must be concise. 16.21. What is the difference between the Value added (% of GDP) of Industry in 1992 and the Value added (% of GDP) of Services in 1997?
Your answer should be very brief. -29.15. What is the difference between the Value added (% of GDP) in Industry in 1992 and the Value added (% of GDP) in Agriculture in 1997?
Your answer should be compact. 34.9. What is the difference between the Value added (% of GDP) of Manufacturing in 1992 and the Value added (% of GDP) of Services in 1997?
Provide a short and direct response. -46.31. What is the difference between the Value added (% of GDP) of Manufacturing in 1992 and the Value added (% of GDP) of Agriculture in 1997?
Give a very brief answer. 17.74. What is the difference between the Value added (% of GDP) in Services in 1992 and the Value added (% of GDP) in Agriculture in 1997?
Ensure brevity in your answer.  59.95. What is the difference between the Value added (% of GDP) in Industry in 1993 and the Value added (% of GDP) in Manufacturing in 1994?
Offer a terse response. 15.42. What is the difference between the Value added (% of GDP) in Industry in 1993 and the Value added (% of GDP) in Services in 1994?
Keep it short and to the point. -29.24. What is the difference between the Value added (% of GDP) of Industry in 1993 and the Value added (% of GDP) of Agriculture in 1994?
Your answer should be compact. 33.17. What is the difference between the Value added (% of GDP) in Manufacturing in 1993 and the Value added (% of GDP) in Services in 1994?
Make the answer very short. -44.86. What is the difference between the Value added (% of GDP) in Manufacturing in 1993 and the Value added (% of GDP) in Agriculture in 1994?
Offer a terse response. 17.55. What is the difference between the Value added (% of GDP) in Services in 1993 and the Value added (% of GDP) in Agriculture in 1994?
Your answer should be compact. 61.14. What is the difference between the Value added (% of GDP) of Industry in 1993 and the Value added (% of GDP) of Manufacturing in 1995?
Provide a succinct answer. 15.23. What is the difference between the Value added (% of GDP) in Industry in 1993 and the Value added (% of GDP) in Services in 1995?
Your answer should be very brief. -30.04. What is the difference between the Value added (% of GDP) of Industry in 1993 and the Value added (% of GDP) of Agriculture in 1995?
Offer a very short reply. 33.4. What is the difference between the Value added (% of GDP) of Manufacturing in 1993 and the Value added (% of GDP) of Services in 1995?
Make the answer very short. -45.66. What is the difference between the Value added (% of GDP) in Manufacturing in 1993 and the Value added (% of GDP) in Agriculture in 1995?
Ensure brevity in your answer.  17.78. What is the difference between the Value added (% of GDP) in Services in 1993 and the Value added (% of GDP) in Agriculture in 1995?
Ensure brevity in your answer.  61.37. What is the difference between the Value added (% of GDP) of Industry in 1993 and the Value added (% of GDP) of Manufacturing in 1996?
Keep it short and to the point. 15.23. What is the difference between the Value added (% of GDP) of Industry in 1993 and the Value added (% of GDP) of Services in 1996?
Your answer should be compact. -30.2. What is the difference between the Value added (% of GDP) in Industry in 1993 and the Value added (% of GDP) in Agriculture in 1996?
Ensure brevity in your answer.  33.38. What is the difference between the Value added (% of GDP) in Manufacturing in 1993 and the Value added (% of GDP) in Services in 1996?
Provide a short and direct response. -45.82. What is the difference between the Value added (% of GDP) of Manufacturing in 1993 and the Value added (% of GDP) of Agriculture in 1996?
Your answer should be compact. 17.76. What is the difference between the Value added (% of GDP) of Services in 1993 and the Value added (% of GDP) of Agriculture in 1996?
Provide a short and direct response. 61.36. What is the difference between the Value added (% of GDP) in Industry in 1993 and the Value added (% of GDP) in Manufacturing in 1997?
Give a very brief answer. 14.82. What is the difference between the Value added (% of GDP) in Industry in 1993 and the Value added (% of GDP) in Services in 1997?
Your answer should be compact. -30.53. What is the difference between the Value added (% of GDP) in Industry in 1993 and the Value added (% of GDP) in Agriculture in 1997?
Give a very brief answer. 33.52. What is the difference between the Value added (% of GDP) of Manufacturing in 1993 and the Value added (% of GDP) of Services in 1997?
Give a very brief answer. -46.15. What is the difference between the Value added (% of GDP) in Manufacturing in 1993 and the Value added (% of GDP) in Agriculture in 1997?
Your answer should be compact. 17.9. What is the difference between the Value added (% of GDP) in Services in 1993 and the Value added (% of GDP) in Agriculture in 1997?
Your answer should be very brief. 61.49. What is the difference between the Value added (% of GDP) in Industry in 1994 and the Value added (% of GDP) in Manufacturing in 1995?
Offer a terse response. 13.71. What is the difference between the Value added (% of GDP) in Industry in 1994 and the Value added (% of GDP) in Services in 1995?
Your answer should be compact. -31.56. What is the difference between the Value added (% of GDP) in Industry in 1994 and the Value added (% of GDP) in Agriculture in 1995?
Your response must be concise. 31.88. What is the difference between the Value added (% of GDP) in Manufacturing in 1994 and the Value added (% of GDP) in Services in 1995?
Your response must be concise. -45.46. What is the difference between the Value added (% of GDP) in Manufacturing in 1994 and the Value added (% of GDP) in Agriculture in 1995?
Your response must be concise. 17.98. What is the difference between the Value added (% of GDP) of Services in 1994 and the Value added (% of GDP) of Agriculture in 1995?
Offer a very short reply. 62.64. What is the difference between the Value added (% of GDP) in Industry in 1994 and the Value added (% of GDP) in Manufacturing in 1996?
Provide a short and direct response. 13.71. What is the difference between the Value added (% of GDP) in Industry in 1994 and the Value added (% of GDP) in Services in 1996?
Make the answer very short. -31.72. What is the difference between the Value added (% of GDP) of Industry in 1994 and the Value added (% of GDP) of Agriculture in 1996?
Offer a terse response. 31.86. What is the difference between the Value added (% of GDP) in Manufacturing in 1994 and the Value added (% of GDP) in Services in 1996?
Your response must be concise. -45.62. What is the difference between the Value added (% of GDP) of Manufacturing in 1994 and the Value added (% of GDP) of Agriculture in 1996?
Your answer should be very brief. 17.96. What is the difference between the Value added (% of GDP) of Services in 1994 and the Value added (% of GDP) of Agriculture in 1996?
Your response must be concise. 62.62. What is the difference between the Value added (% of GDP) in Industry in 1994 and the Value added (% of GDP) in Manufacturing in 1997?
Your answer should be very brief. 13.3. What is the difference between the Value added (% of GDP) in Industry in 1994 and the Value added (% of GDP) in Services in 1997?
Offer a very short reply. -32.05. What is the difference between the Value added (% of GDP) in Industry in 1994 and the Value added (% of GDP) in Agriculture in 1997?
Your response must be concise. 32. What is the difference between the Value added (% of GDP) of Manufacturing in 1994 and the Value added (% of GDP) of Services in 1997?
Give a very brief answer. -45.95. What is the difference between the Value added (% of GDP) of Manufacturing in 1994 and the Value added (% of GDP) of Agriculture in 1997?
Make the answer very short. 18.1. What is the difference between the Value added (% of GDP) of Services in 1994 and the Value added (% of GDP) of Agriculture in 1997?
Ensure brevity in your answer.  62.76. What is the difference between the Value added (% of GDP) of Industry in 1995 and the Value added (% of GDP) of Manufacturing in 1996?
Offer a very short reply. 13.14. What is the difference between the Value added (% of GDP) in Industry in 1995 and the Value added (% of GDP) in Services in 1996?
Offer a terse response. -32.28. What is the difference between the Value added (% of GDP) in Industry in 1995 and the Value added (% of GDP) in Agriculture in 1996?
Offer a terse response. 31.3. What is the difference between the Value added (% of GDP) of Manufacturing in 1995 and the Value added (% of GDP) of Services in 1996?
Provide a short and direct response. -45.43. What is the difference between the Value added (% of GDP) in Manufacturing in 1995 and the Value added (% of GDP) in Agriculture in 1996?
Ensure brevity in your answer.  18.15. What is the difference between the Value added (% of GDP) of Services in 1995 and the Value added (% of GDP) of Agriculture in 1996?
Give a very brief answer. 63.42. What is the difference between the Value added (% of GDP) in Industry in 1995 and the Value added (% of GDP) in Manufacturing in 1997?
Make the answer very short. 12.74. What is the difference between the Value added (% of GDP) in Industry in 1995 and the Value added (% of GDP) in Services in 1997?
Your answer should be compact. -32.62. What is the difference between the Value added (% of GDP) of Industry in 1995 and the Value added (% of GDP) of Agriculture in 1997?
Provide a succinct answer. 31.43. What is the difference between the Value added (% of GDP) of Manufacturing in 1995 and the Value added (% of GDP) of Services in 1997?
Your response must be concise. -45.77. What is the difference between the Value added (% of GDP) in Manufacturing in 1995 and the Value added (% of GDP) in Agriculture in 1997?
Provide a short and direct response. 18.29. What is the difference between the Value added (% of GDP) of Services in 1995 and the Value added (% of GDP) of Agriculture in 1997?
Make the answer very short. 63.56. What is the difference between the Value added (% of GDP) in Industry in 1996 and the Value added (% of GDP) in Manufacturing in 1997?
Your answer should be very brief. 12.56. What is the difference between the Value added (% of GDP) of Industry in 1996 and the Value added (% of GDP) of Services in 1997?
Your answer should be very brief. -32.8. What is the difference between the Value added (% of GDP) of Industry in 1996 and the Value added (% of GDP) of Agriculture in 1997?
Offer a very short reply. 31.26. What is the difference between the Value added (% of GDP) in Manufacturing in 1996 and the Value added (% of GDP) in Services in 1997?
Your response must be concise. -45.76. What is the difference between the Value added (% of GDP) of Manufacturing in 1996 and the Value added (% of GDP) of Agriculture in 1997?
Make the answer very short. 18.29. What is the difference between the Value added (% of GDP) in Services in 1996 and the Value added (% of GDP) in Agriculture in 1997?
Make the answer very short. 63.72. What is the average Value added (% of GDP) of Industry per year?
Offer a very short reply. 35.28. What is the average Value added (% of GDP) of Manufacturing per year?
Your answer should be very brief. 20.1. What is the average Value added (% of GDP) of Services per year?
Offer a terse response. 62.83. What is the average Value added (% of GDP) of Agriculture per year?
Offer a terse response. 1.89. In the year 1989, what is the difference between the Value added (% of GDP) of Industry and Value added (% of GDP) of Manufacturing?
Keep it short and to the point. 16.73. In the year 1989, what is the difference between the Value added (% of GDP) in Industry and Value added (% of GDP) in Services?
Provide a succinct answer. -22.25. In the year 1989, what is the difference between the Value added (% of GDP) of Industry and Value added (% of GDP) of Agriculture?
Your response must be concise. 35.6. In the year 1989, what is the difference between the Value added (% of GDP) of Manufacturing and Value added (% of GDP) of Services?
Your response must be concise. -38.98. In the year 1989, what is the difference between the Value added (% of GDP) of Manufacturing and Value added (% of GDP) of Agriculture?
Your answer should be compact. 18.87. In the year 1989, what is the difference between the Value added (% of GDP) in Services and Value added (% of GDP) in Agriculture?
Give a very brief answer. 57.85. In the year 1990, what is the difference between the Value added (% of GDP) in Industry and Value added (% of GDP) in Manufacturing?
Ensure brevity in your answer.  16.88. In the year 1990, what is the difference between the Value added (% of GDP) of Industry and Value added (% of GDP) of Services?
Your answer should be very brief. -21.77. In the year 1990, what is the difference between the Value added (% of GDP) in Industry and Value added (% of GDP) in Agriculture?
Your answer should be compact. 35.93. In the year 1990, what is the difference between the Value added (% of GDP) in Manufacturing and Value added (% of GDP) in Services?
Keep it short and to the point. -38.66. In the year 1990, what is the difference between the Value added (% of GDP) of Manufacturing and Value added (% of GDP) of Agriculture?
Make the answer very short. 19.05. In the year 1990, what is the difference between the Value added (% of GDP) of Services and Value added (% of GDP) of Agriculture?
Provide a succinct answer. 57.7. In the year 1991, what is the difference between the Value added (% of GDP) of Industry and Value added (% of GDP) of Manufacturing?
Keep it short and to the point. 17.81. In the year 1991, what is the difference between the Value added (% of GDP) of Industry and Value added (% of GDP) of Services?
Your answer should be compact. -22.64. In the year 1991, what is the difference between the Value added (% of GDP) in Industry and Value added (% of GDP) in Agriculture?
Your answer should be very brief. 35.71. In the year 1991, what is the difference between the Value added (% of GDP) in Manufacturing and Value added (% of GDP) in Services?
Offer a very short reply. -40.45. In the year 1991, what is the difference between the Value added (% of GDP) of Manufacturing and Value added (% of GDP) of Agriculture?
Make the answer very short. 17.9. In the year 1991, what is the difference between the Value added (% of GDP) of Services and Value added (% of GDP) of Agriculture?
Your answer should be very brief. 58.35. In the year 1992, what is the difference between the Value added (% of GDP) of Industry and Value added (% of GDP) of Manufacturing?
Provide a succinct answer. 17.16. In the year 1992, what is the difference between the Value added (% of GDP) in Industry and Value added (% of GDP) in Services?
Your answer should be compact. -25.05. In the year 1992, what is the difference between the Value added (% of GDP) of Industry and Value added (% of GDP) of Agriculture?
Give a very brief answer. 34.64. In the year 1992, what is the difference between the Value added (% of GDP) of Manufacturing and Value added (% of GDP) of Services?
Make the answer very short. -42.21. In the year 1992, what is the difference between the Value added (% of GDP) in Manufacturing and Value added (% of GDP) in Agriculture?
Your answer should be very brief. 17.49. In the year 1992, what is the difference between the Value added (% of GDP) of Services and Value added (% of GDP) of Agriculture?
Provide a short and direct response. 59.7. In the year 1993, what is the difference between the Value added (% of GDP) in Industry and Value added (% of GDP) in Manufacturing?
Provide a succinct answer. 15.62. In the year 1993, what is the difference between the Value added (% of GDP) of Industry and Value added (% of GDP) of Services?
Offer a very short reply. -27.97. In the year 1993, what is the difference between the Value added (% of GDP) of Industry and Value added (% of GDP) of Agriculture?
Offer a very short reply. 33.42. In the year 1993, what is the difference between the Value added (% of GDP) in Manufacturing and Value added (% of GDP) in Services?
Your response must be concise. -43.59. In the year 1993, what is the difference between the Value added (% of GDP) of Manufacturing and Value added (% of GDP) of Agriculture?
Offer a terse response. 17.8. In the year 1993, what is the difference between the Value added (% of GDP) in Services and Value added (% of GDP) in Agriculture?
Provide a succinct answer. 61.4. In the year 1994, what is the difference between the Value added (% of GDP) in Industry and Value added (% of GDP) in Manufacturing?
Keep it short and to the point. 13.9. In the year 1994, what is the difference between the Value added (% of GDP) of Industry and Value added (% of GDP) of Services?
Give a very brief answer. -30.76. In the year 1994, what is the difference between the Value added (% of GDP) in Industry and Value added (% of GDP) in Agriculture?
Offer a terse response. 31.65. In the year 1994, what is the difference between the Value added (% of GDP) in Manufacturing and Value added (% of GDP) in Services?
Offer a terse response. -44.66. In the year 1994, what is the difference between the Value added (% of GDP) of Manufacturing and Value added (% of GDP) of Agriculture?
Your answer should be very brief. 17.75. In the year 1994, what is the difference between the Value added (% of GDP) of Services and Value added (% of GDP) of Agriculture?
Ensure brevity in your answer.  62.41. In the year 1995, what is the difference between the Value added (% of GDP) of Industry and Value added (% of GDP) of Manufacturing?
Your response must be concise. 13.15. In the year 1995, what is the difference between the Value added (% of GDP) in Industry and Value added (% of GDP) in Services?
Offer a terse response. -32.12. In the year 1995, what is the difference between the Value added (% of GDP) of Industry and Value added (% of GDP) of Agriculture?
Give a very brief answer. 31.31. In the year 1995, what is the difference between the Value added (% of GDP) in Manufacturing and Value added (% of GDP) in Services?
Provide a short and direct response. -45.27. In the year 1995, what is the difference between the Value added (% of GDP) of Manufacturing and Value added (% of GDP) of Agriculture?
Your answer should be compact. 18.17. In the year 1995, what is the difference between the Value added (% of GDP) of Services and Value added (% of GDP) of Agriculture?
Your answer should be compact. 63.44. In the year 1996, what is the difference between the Value added (% of GDP) of Industry and Value added (% of GDP) of Manufacturing?
Your response must be concise. 12.96. In the year 1996, what is the difference between the Value added (% of GDP) in Industry and Value added (% of GDP) in Services?
Provide a short and direct response. -32.46. In the year 1996, what is the difference between the Value added (% of GDP) of Industry and Value added (% of GDP) of Agriculture?
Keep it short and to the point. 31.12. In the year 1996, what is the difference between the Value added (% of GDP) in Manufacturing and Value added (% of GDP) in Services?
Your answer should be very brief. -45.43. In the year 1996, what is the difference between the Value added (% of GDP) in Manufacturing and Value added (% of GDP) in Agriculture?
Make the answer very short. 18.16. In the year 1996, what is the difference between the Value added (% of GDP) in Services and Value added (% of GDP) in Agriculture?
Provide a short and direct response. 63.58. In the year 1997, what is the difference between the Value added (% of GDP) of Industry and Value added (% of GDP) of Manufacturing?
Your answer should be very brief. 12.36. In the year 1997, what is the difference between the Value added (% of GDP) in Industry and Value added (% of GDP) in Services?
Your answer should be compact. -32.99. In the year 1997, what is the difference between the Value added (% of GDP) in Industry and Value added (% of GDP) in Agriculture?
Keep it short and to the point. 31.06. In the year 1997, what is the difference between the Value added (% of GDP) of Manufacturing and Value added (% of GDP) of Services?
Your answer should be very brief. -45.36. In the year 1997, what is the difference between the Value added (% of GDP) in Manufacturing and Value added (% of GDP) in Agriculture?
Provide a short and direct response. 18.7. In the year 1997, what is the difference between the Value added (% of GDP) of Services and Value added (% of GDP) of Agriculture?
Offer a terse response. 64.05. What is the ratio of the Value added (% of GDP) of Agriculture in 1989 to that in 1990?
Offer a very short reply. 1.03. What is the ratio of the Value added (% of GDP) in Industry in 1989 to that in 1991?
Keep it short and to the point. 1. What is the ratio of the Value added (% of GDP) of Manufacturing in 1989 to that in 1991?
Offer a terse response. 1.06. What is the ratio of the Value added (% of GDP) in Services in 1989 to that in 1991?
Offer a very short reply. 1. What is the ratio of the Value added (% of GDP) of Agriculture in 1989 to that in 1991?
Provide a succinct answer. 1.1. What is the ratio of the Value added (% of GDP) of Industry in 1989 to that in 1992?
Provide a succinct answer. 1.03. What is the ratio of the Value added (% of GDP) of Manufacturing in 1989 to that in 1992?
Offer a very short reply. 1.09. What is the ratio of the Value added (% of GDP) of Services in 1989 to that in 1992?
Make the answer very short. 0.97. What is the ratio of the Value added (% of GDP) in Agriculture in 1989 to that in 1992?
Your answer should be very brief. 1.16. What is the ratio of the Value added (% of GDP) in Industry in 1989 to that in 1993?
Offer a very short reply. 1.07. What is the ratio of the Value added (% of GDP) in Manufacturing in 1989 to that in 1993?
Your response must be concise. 1.08. What is the ratio of the Value added (% of GDP) in Services in 1989 to that in 1993?
Provide a short and direct response. 0.95. What is the ratio of the Value added (% of GDP) in Agriculture in 1989 to that in 1993?
Your response must be concise. 1.26. What is the ratio of the Value added (% of GDP) in Industry in 1989 to that in 1994?
Provide a short and direct response. 1.12. What is the ratio of the Value added (% of GDP) of Manufacturing in 1989 to that in 1994?
Ensure brevity in your answer.  1.07. What is the ratio of the Value added (% of GDP) in Services in 1989 to that in 1994?
Ensure brevity in your answer.  0.93. What is the ratio of the Value added (% of GDP) in Agriculture in 1989 to that in 1994?
Ensure brevity in your answer.  1.1. What is the ratio of the Value added (% of GDP) in Industry in 1989 to that in 1995?
Your response must be concise. 1.14. What is the ratio of the Value added (% of GDP) in Manufacturing in 1989 to that in 1995?
Provide a succinct answer. 1.06. What is the ratio of the Value added (% of GDP) in Services in 1989 to that in 1995?
Ensure brevity in your answer.  0.92. What is the ratio of the Value added (% of GDP) in Agriculture in 1989 to that in 1995?
Give a very brief answer. 1.25. What is the ratio of the Value added (% of GDP) of Industry in 1989 to that in 1996?
Provide a succinct answer. 1.15. What is the ratio of the Value added (% of GDP) in Manufacturing in 1989 to that in 1996?
Your answer should be compact. 1.06. What is the ratio of the Value added (% of GDP) of Services in 1989 to that in 1996?
Ensure brevity in your answer.  0.92. What is the ratio of the Value added (% of GDP) of Agriculture in 1989 to that in 1996?
Provide a short and direct response. 1.24. What is the ratio of the Value added (% of GDP) of Industry in 1989 to that in 1997?
Provide a short and direct response. 1.16. What is the ratio of the Value added (% of GDP) in Manufacturing in 1989 to that in 1997?
Make the answer very short. 1.04. What is the ratio of the Value added (% of GDP) of Services in 1989 to that in 1997?
Make the answer very short. 0.91. What is the ratio of the Value added (% of GDP) in Agriculture in 1989 to that in 1997?
Offer a terse response. 1.34. What is the ratio of the Value added (% of GDP) in Industry in 1990 to that in 1991?
Ensure brevity in your answer.  1.01. What is the ratio of the Value added (% of GDP) in Manufacturing in 1990 to that in 1991?
Your answer should be very brief. 1.06. What is the ratio of the Value added (% of GDP) in Services in 1990 to that in 1991?
Keep it short and to the point. 0.99. What is the ratio of the Value added (% of GDP) of Agriculture in 1990 to that in 1991?
Make the answer very short. 1.07. What is the ratio of the Value added (% of GDP) in Industry in 1990 to that in 1992?
Offer a very short reply. 1.04. What is the ratio of the Value added (% of GDP) of Manufacturing in 1990 to that in 1992?
Provide a short and direct response. 1.09. What is the ratio of the Value added (% of GDP) in Services in 1990 to that in 1992?
Provide a succinct answer. 0.97. What is the ratio of the Value added (% of GDP) in Agriculture in 1990 to that in 1992?
Provide a succinct answer. 1.12. What is the ratio of the Value added (% of GDP) in Industry in 1990 to that in 1993?
Offer a very short reply. 1.08. What is the ratio of the Value added (% of GDP) of Manufacturing in 1990 to that in 1993?
Give a very brief answer. 1.08. What is the ratio of the Value added (% of GDP) in Services in 1990 to that in 1993?
Provide a short and direct response. 0.95. What is the ratio of the Value added (% of GDP) in Agriculture in 1990 to that in 1993?
Your answer should be very brief. 1.23. What is the ratio of the Value added (% of GDP) in Industry in 1990 to that in 1994?
Ensure brevity in your answer.  1.13. What is the ratio of the Value added (% of GDP) in Manufacturing in 1990 to that in 1994?
Make the answer very short. 1.07. What is the ratio of the Value added (% of GDP) of Services in 1990 to that in 1994?
Make the answer very short. 0.93. What is the ratio of the Value added (% of GDP) in Agriculture in 1990 to that in 1994?
Offer a very short reply. 1.07. What is the ratio of the Value added (% of GDP) of Industry in 1990 to that in 1995?
Give a very brief answer. 1.15. What is the ratio of the Value added (% of GDP) of Manufacturing in 1990 to that in 1995?
Provide a short and direct response. 1.06. What is the ratio of the Value added (% of GDP) in Services in 1990 to that in 1995?
Your response must be concise. 0.92. What is the ratio of the Value added (% of GDP) in Agriculture in 1990 to that in 1995?
Give a very brief answer. 1.21. What is the ratio of the Value added (% of GDP) of Industry in 1990 to that in 1996?
Keep it short and to the point. 1.16. What is the ratio of the Value added (% of GDP) of Manufacturing in 1990 to that in 1996?
Offer a very short reply. 1.06. What is the ratio of the Value added (% of GDP) in Services in 1990 to that in 1996?
Your answer should be very brief. 0.92. What is the ratio of the Value added (% of GDP) in Agriculture in 1990 to that in 1996?
Keep it short and to the point. 1.2. What is the ratio of the Value added (% of GDP) in Industry in 1990 to that in 1997?
Your answer should be compact. 1.16. What is the ratio of the Value added (% of GDP) of Manufacturing in 1990 to that in 1997?
Ensure brevity in your answer.  1.04. What is the ratio of the Value added (% of GDP) of Services in 1990 to that in 1997?
Provide a succinct answer. 0.91. What is the ratio of the Value added (% of GDP) of Agriculture in 1990 to that in 1997?
Offer a terse response. 1.3. What is the ratio of the Value added (% of GDP) in Industry in 1991 to that in 1992?
Offer a terse response. 1.03. What is the ratio of the Value added (% of GDP) in Manufacturing in 1991 to that in 1992?
Provide a short and direct response. 1.03. What is the ratio of the Value added (% of GDP) in Services in 1991 to that in 1992?
Provide a succinct answer. 0.98. What is the ratio of the Value added (% of GDP) of Agriculture in 1991 to that in 1992?
Offer a very short reply. 1.05. What is the ratio of the Value added (% of GDP) of Industry in 1991 to that in 1993?
Give a very brief answer. 1.07. What is the ratio of the Value added (% of GDP) of Services in 1991 to that in 1993?
Ensure brevity in your answer.  0.96. What is the ratio of the Value added (% of GDP) of Agriculture in 1991 to that in 1993?
Provide a short and direct response. 1.15. What is the ratio of the Value added (% of GDP) in Industry in 1991 to that in 1994?
Offer a terse response. 1.12. What is the ratio of the Value added (% of GDP) in Manufacturing in 1991 to that in 1994?
Provide a short and direct response. 1.01. What is the ratio of the Value added (% of GDP) in Services in 1991 to that in 1994?
Your response must be concise. 0.94. What is the ratio of the Value added (% of GDP) of Industry in 1991 to that in 1995?
Provide a short and direct response. 1.14. What is the ratio of the Value added (% of GDP) of Manufacturing in 1991 to that in 1995?
Offer a terse response. 1. What is the ratio of the Value added (% of GDP) in Services in 1991 to that in 1995?
Offer a terse response. 0.93. What is the ratio of the Value added (% of GDP) of Agriculture in 1991 to that in 1995?
Give a very brief answer. 1.13. What is the ratio of the Value added (% of GDP) of Industry in 1991 to that in 1996?
Your answer should be compact. 1.15. What is the ratio of the Value added (% of GDP) in Services in 1991 to that in 1996?
Offer a very short reply. 0.92. What is the ratio of the Value added (% of GDP) of Agriculture in 1991 to that in 1996?
Keep it short and to the point. 1.12. What is the ratio of the Value added (% of GDP) in Industry in 1991 to that in 1997?
Offer a terse response. 1.15. What is the ratio of the Value added (% of GDP) of Manufacturing in 1991 to that in 1997?
Make the answer very short. 0.98. What is the ratio of the Value added (% of GDP) in Services in 1991 to that in 1997?
Your response must be concise. 0.92. What is the ratio of the Value added (% of GDP) of Agriculture in 1991 to that in 1997?
Give a very brief answer. 1.21. What is the ratio of the Value added (% of GDP) in Industry in 1992 to that in 1993?
Provide a short and direct response. 1.04. What is the ratio of the Value added (% of GDP) of Services in 1992 to that in 1993?
Your answer should be very brief. 0.98. What is the ratio of the Value added (% of GDP) of Agriculture in 1992 to that in 1993?
Your response must be concise. 1.09. What is the ratio of the Value added (% of GDP) in Industry in 1992 to that in 1994?
Provide a succinct answer. 1.09. What is the ratio of the Value added (% of GDP) in Manufacturing in 1992 to that in 1994?
Provide a short and direct response. 0.98. What is the ratio of the Value added (% of GDP) of Services in 1992 to that in 1994?
Your answer should be very brief. 0.96. What is the ratio of the Value added (% of GDP) of Agriculture in 1992 to that in 1994?
Provide a short and direct response. 0.95. What is the ratio of the Value added (% of GDP) of Industry in 1992 to that in 1995?
Give a very brief answer. 1.1. What is the ratio of the Value added (% of GDP) of Manufacturing in 1992 to that in 1995?
Offer a terse response. 0.97. What is the ratio of the Value added (% of GDP) of Services in 1992 to that in 1995?
Offer a terse response. 0.94. What is the ratio of the Value added (% of GDP) of Agriculture in 1992 to that in 1995?
Provide a short and direct response. 1.08. What is the ratio of the Value added (% of GDP) in Industry in 1992 to that in 1996?
Keep it short and to the point. 1.11. What is the ratio of the Value added (% of GDP) of Manufacturing in 1992 to that in 1996?
Your answer should be very brief. 0.97. What is the ratio of the Value added (% of GDP) in Services in 1992 to that in 1996?
Offer a very short reply. 0.94. What is the ratio of the Value added (% of GDP) of Agriculture in 1992 to that in 1996?
Keep it short and to the point. 1.07. What is the ratio of the Value added (% of GDP) of Industry in 1992 to that in 1997?
Offer a very short reply. 1.12. What is the ratio of the Value added (% of GDP) in Manufacturing in 1992 to that in 1997?
Your answer should be compact. 0.95. What is the ratio of the Value added (% of GDP) in Services in 1992 to that in 1997?
Your answer should be very brief. 0.94. What is the ratio of the Value added (% of GDP) in Agriculture in 1992 to that in 1997?
Make the answer very short. 1.16. What is the ratio of the Value added (% of GDP) of Industry in 1993 to that in 1994?
Keep it short and to the point. 1.05. What is the ratio of the Value added (% of GDP) of Manufacturing in 1993 to that in 1994?
Offer a terse response. 0.99. What is the ratio of the Value added (% of GDP) of Services in 1993 to that in 1994?
Make the answer very short. 0.98. What is the ratio of the Value added (% of GDP) in Agriculture in 1993 to that in 1994?
Provide a succinct answer. 0.87. What is the ratio of the Value added (% of GDP) in Industry in 1993 to that in 1995?
Ensure brevity in your answer.  1.06. What is the ratio of the Value added (% of GDP) in Manufacturing in 1993 to that in 1995?
Your response must be concise. 0.98. What is the ratio of the Value added (% of GDP) in Services in 1993 to that in 1995?
Keep it short and to the point. 0.97. What is the ratio of the Value added (% of GDP) in Agriculture in 1993 to that in 1995?
Offer a terse response. 0.99. What is the ratio of the Value added (% of GDP) in Industry in 1993 to that in 1996?
Keep it short and to the point. 1.07. What is the ratio of the Value added (% of GDP) of Manufacturing in 1993 to that in 1996?
Your response must be concise. 0.98. What is the ratio of the Value added (% of GDP) of Services in 1993 to that in 1996?
Ensure brevity in your answer.  0.97. What is the ratio of the Value added (% of GDP) of Agriculture in 1993 to that in 1996?
Your response must be concise. 0.98. What is the ratio of the Value added (% of GDP) of Industry in 1993 to that in 1997?
Provide a succinct answer. 1.08. What is the ratio of the Value added (% of GDP) in Manufacturing in 1993 to that in 1997?
Offer a very short reply. 0.96. What is the ratio of the Value added (% of GDP) in Agriculture in 1993 to that in 1997?
Your answer should be compact. 1.06. What is the ratio of the Value added (% of GDP) of Industry in 1994 to that in 1995?
Provide a short and direct response. 1.02. What is the ratio of the Value added (% of GDP) in Manufacturing in 1994 to that in 1995?
Keep it short and to the point. 0.99. What is the ratio of the Value added (% of GDP) in Services in 1994 to that in 1995?
Your response must be concise. 0.99. What is the ratio of the Value added (% of GDP) of Agriculture in 1994 to that in 1995?
Your answer should be very brief. 1.13. What is the ratio of the Value added (% of GDP) in Industry in 1994 to that in 1996?
Ensure brevity in your answer.  1.02. What is the ratio of the Value added (% of GDP) in Manufacturing in 1994 to that in 1996?
Give a very brief answer. 0.99. What is the ratio of the Value added (% of GDP) of Services in 1994 to that in 1996?
Make the answer very short. 0.99. What is the ratio of the Value added (% of GDP) of Agriculture in 1994 to that in 1996?
Offer a very short reply. 1.12. What is the ratio of the Value added (% of GDP) of Industry in 1994 to that in 1997?
Ensure brevity in your answer.  1.03. What is the ratio of the Value added (% of GDP) of Manufacturing in 1994 to that in 1997?
Offer a very short reply. 0.97. What is the ratio of the Value added (% of GDP) in Services in 1994 to that in 1997?
Keep it short and to the point. 0.98. What is the ratio of the Value added (% of GDP) of Agriculture in 1994 to that in 1997?
Your response must be concise. 1.22. What is the ratio of the Value added (% of GDP) in Industry in 1995 to that in 1996?
Make the answer very short. 1.01. What is the ratio of the Value added (% of GDP) of Services in 1995 to that in 1996?
Your answer should be compact. 1. What is the ratio of the Value added (% of GDP) of Agriculture in 1995 to that in 1996?
Give a very brief answer. 0.99. What is the ratio of the Value added (% of GDP) in Industry in 1995 to that in 1997?
Provide a succinct answer. 1.01. What is the ratio of the Value added (% of GDP) of Manufacturing in 1995 to that in 1997?
Give a very brief answer. 0.98. What is the ratio of the Value added (% of GDP) in Services in 1995 to that in 1997?
Your answer should be very brief. 0.99. What is the ratio of the Value added (% of GDP) in Agriculture in 1995 to that in 1997?
Ensure brevity in your answer.  1.07. What is the ratio of the Value added (% of GDP) in Manufacturing in 1996 to that in 1997?
Provide a succinct answer. 0.98. What is the ratio of the Value added (% of GDP) of Agriculture in 1996 to that in 1997?
Keep it short and to the point. 1.08. What is the difference between the highest and the second highest Value added (% of GDP) in Industry?
Your answer should be very brief. 0.27. What is the difference between the highest and the second highest Value added (% of GDP) of Manufacturing?
Give a very brief answer. 0.11. What is the difference between the highest and the second highest Value added (% of GDP) of Services?
Provide a short and direct response. 0.33. What is the difference between the highest and the second highest Value added (% of GDP) of Agriculture?
Offer a very short reply. 0.06. What is the difference between the highest and the lowest Value added (% of GDP) of Industry?
Your answer should be very brief. 5.37. What is the difference between the highest and the lowest Value added (% of GDP) of Manufacturing?
Your answer should be very brief. 1.8. What is the difference between the highest and the lowest Value added (% of GDP) of Services?
Provide a succinct answer. 5.86. What is the difference between the highest and the lowest Value added (% of GDP) of Agriculture?
Give a very brief answer. 0.55. 